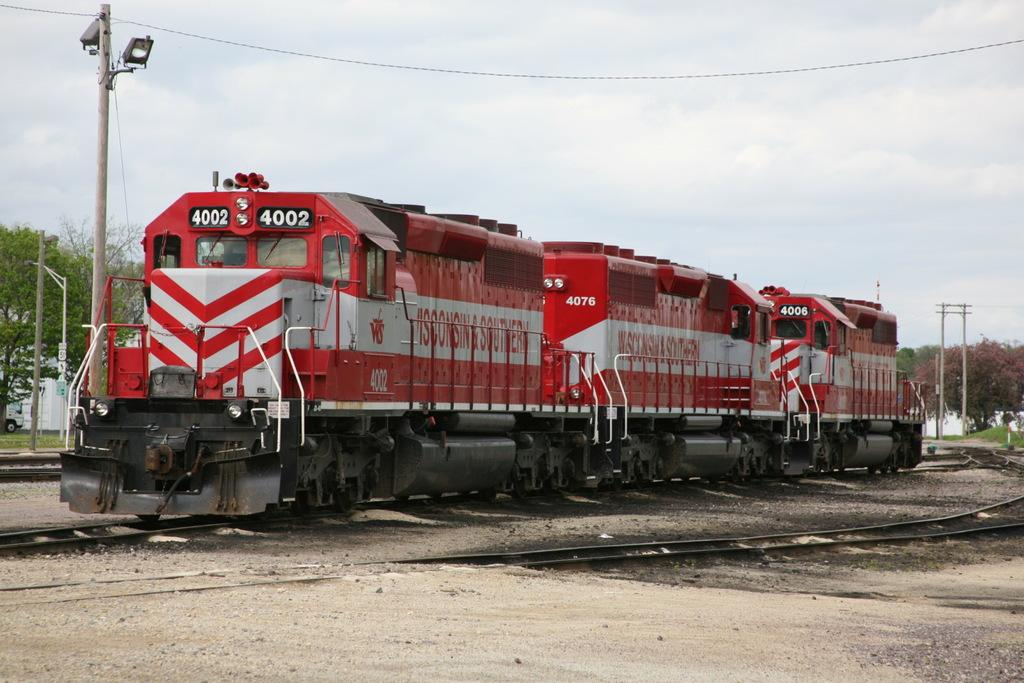What type of vehicle is in the image? There is a red train in the image. Where is the train located? The train is on a railway track. What else can be seen in the image besides the train? Poles, trees, and wires are present in the image. What type of seat is available for passengers in the train? There is no information about seats or passengers in the image, as it only shows a red train on a railway track with poles, trees, and wires. 